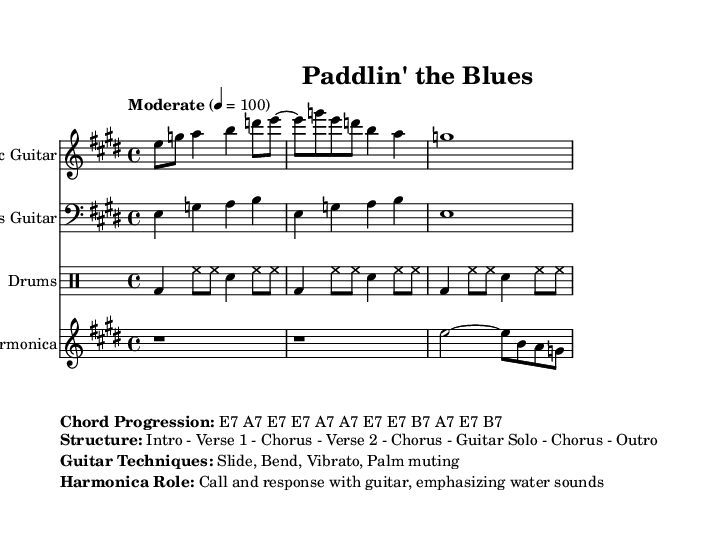What is the key signature of this music? The key signature is E major, which has four sharps (F#, C#, G#, D#). This is indicated at the start of the score in the key signature area.
Answer: E major What is the time signature of this music? The time signature is 4/4, which indicates that there are four beats in a measure and the quarter note gets one beat. This can be found at the beginning of the score, next to the key signature.
Answer: 4/4 What is the tempo marking of this piece? The tempo marking is "Moderate" at 4 = 100, which specifies the speed of the piece. This is indicated at the beginning of the score beneath the time signature.
Answer: Moderate 100 Which section comes after the first chorus? After the first chorus, the structure indicates that there is a "Guitar Solo." This can be found in the section labeled "Structure," which outlines the flow of the song.
Answer: Guitar Solo What are the guitar techniques listed in the score? The guitar techniques listed are Slide, Bend, Vibrato, and Palm muting. These techniques are detailed in the "Guitar Techniques" section of the "Markup" area and are commonly used in Electric Blues.
Answer: Slide, Bend, Vibrato, Palm muting How does the harmonica interact with the guitar? The harmonica's role is to provide a "Call and response with guitar," which emphasizes water sounds. This is stated in the "Harmonica Role" section under the "Markup," showcasing its importance in the piece.
Answer: Call and response 